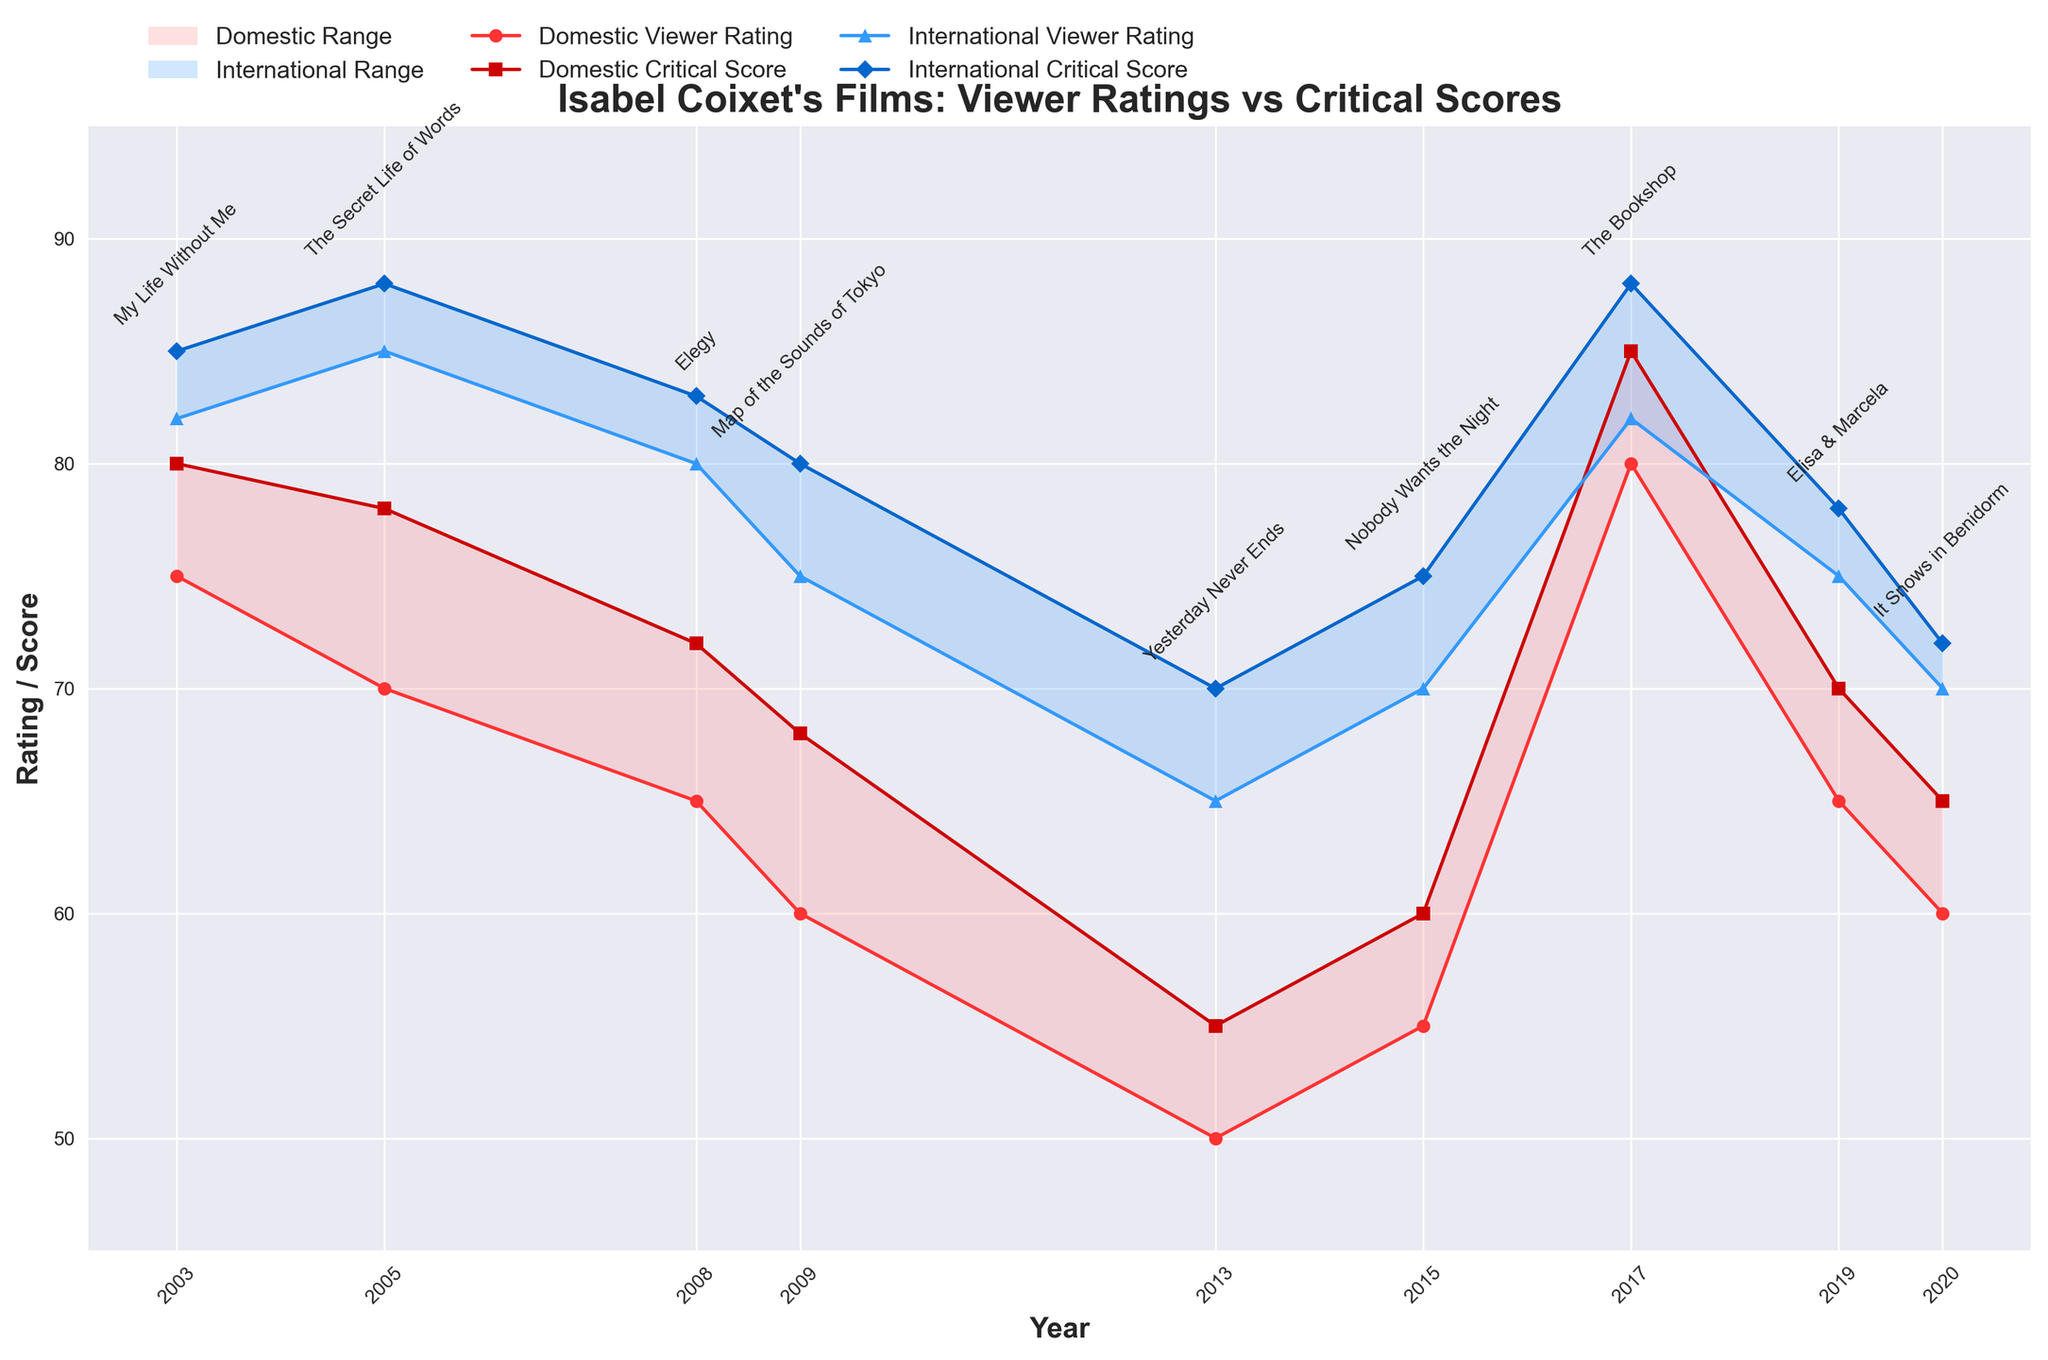What's the title of the chart? The title of the chart is typically placed at the top of the figure. In this case, the title is "Isabel Coixet's Films: Viewer Ratings vs Critical Scores".
Answer: Isabel Coixet's Films: Viewer Ratings vs Critical Scores Which film(s) received the highest domestic critical score? By looking at the domestic critical scores plotted with square markers, we can see that "The Bookshop" received the highest score of 85.
Answer: The Bookshop How did the international viewer rating for "My Life Without Me" compare to its domestic viewer rating? For "My Life Without Me", the international viewer rating is 82, and the domestic viewer rating is 75. Comparing these two values, the international rating is higher.
Answer: Higher Which year had the largest gap between domestic and international critical scores? To find the year with the largest gap, we subtract domestic critical scores from international critical scores for each year. The year 2005 ("The Secret Life of Words") has the highest difference: 10 points (88 - 78).
Answer: 2005 Identify the year where the domestic ratings did not change but the international ratings showed a significant drop. By examining the plot, we notice that from 2008 ("Elegy") to 2009 ("Map of the Sounds of Tokyo"), the domestic ratings were relatively stable (around the 60s). However, the international ratings dropped from 83 to 80 significantly.
Answer: 2009 What is the trend in domestic viewer ratings from 2013 to 2017? Observing the domestic viewer ratings from 2013 to 2017, we can see an increase from 50 (2013) to 80 (2017). This indicates an upward trend in domestic viewer ratings.
Answer: Upward trend Which film has the smallest difference between its domestic viewer rating and international viewer rating? To determine this, we compare the differences for all films, noticing that "The Bookshop" (2017) has the smallest difference (80 - 82 = 2).
Answer: The Bookshop What is the average international critical score for the films directed by Isabel Coixet? Summing up all the international critical scores: 85 (2003) + 88 (2005) + 83 (2008) + 80 (2009) + 70 (2013) + 75 (2015) + 88 (2017) + 78 (2019) + 72 (2020) = 719. Dividing by the number of films (9), the average is 719 / 9 = approximately 79.9.
Answer: 79.9 Are there any films that received identical viewer and critical scores domestically? By examining the data, there are no films where the domestic viewer rating matches the domestic critical score exactly.
Answer: No 